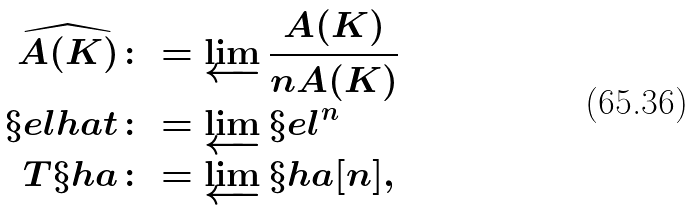<formula> <loc_0><loc_0><loc_500><loc_500>\widehat { A ( K ) } & \colon = \varprojlim \frac { A ( K ) } { n A ( K ) } \\ \S e l h a t & \colon = \varprojlim \S e l ^ { n } \\ T \S h a & \colon = \varprojlim \S h a [ n ] ,</formula> 